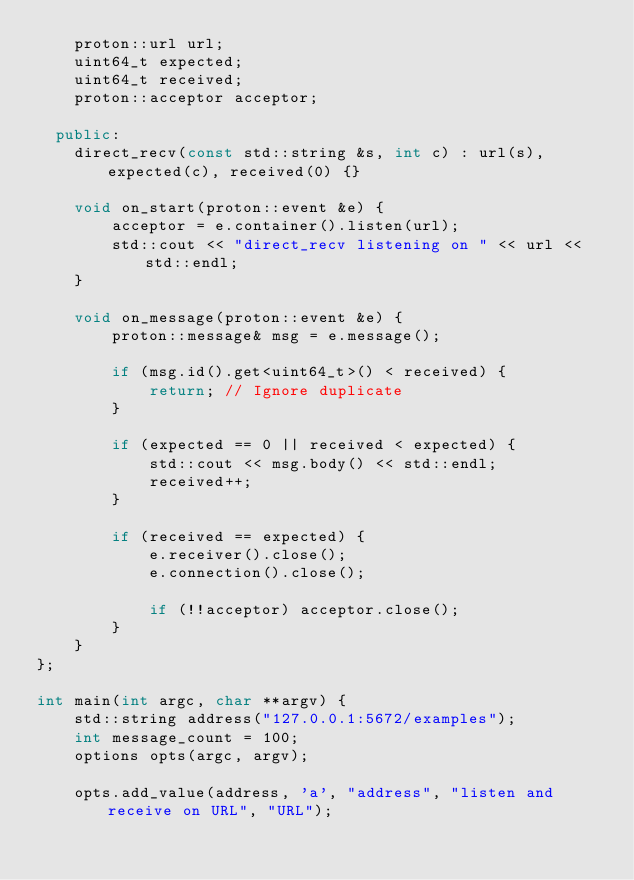<code> <loc_0><loc_0><loc_500><loc_500><_C++_>    proton::url url;
    uint64_t expected;
    uint64_t received;
    proton::acceptor acceptor;

  public:
    direct_recv(const std::string &s, int c) : url(s), expected(c), received(0) {}

    void on_start(proton::event &e) {
        acceptor = e.container().listen(url);
        std::cout << "direct_recv listening on " << url << std::endl;
    }

    void on_message(proton::event &e) {
        proton::message& msg = e.message();
        
        if (msg.id().get<uint64_t>() < received) {
            return; // Ignore duplicate
        }
        
        if (expected == 0 || received < expected) {
            std::cout << msg.body() << std::endl;
            received++;
        }
        
        if (received == expected) {
            e.receiver().close();
            e.connection().close();

            if (!!acceptor) acceptor.close();
        }
    }
};

int main(int argc, char **argv) {
    std::string address("127.0.0.1:5672/examples");
    int message_count = 100;
    options opts(argc, argv);

    opts.add_value(address, 'a', "address", "listen and receive on URL", "URL");</code> 